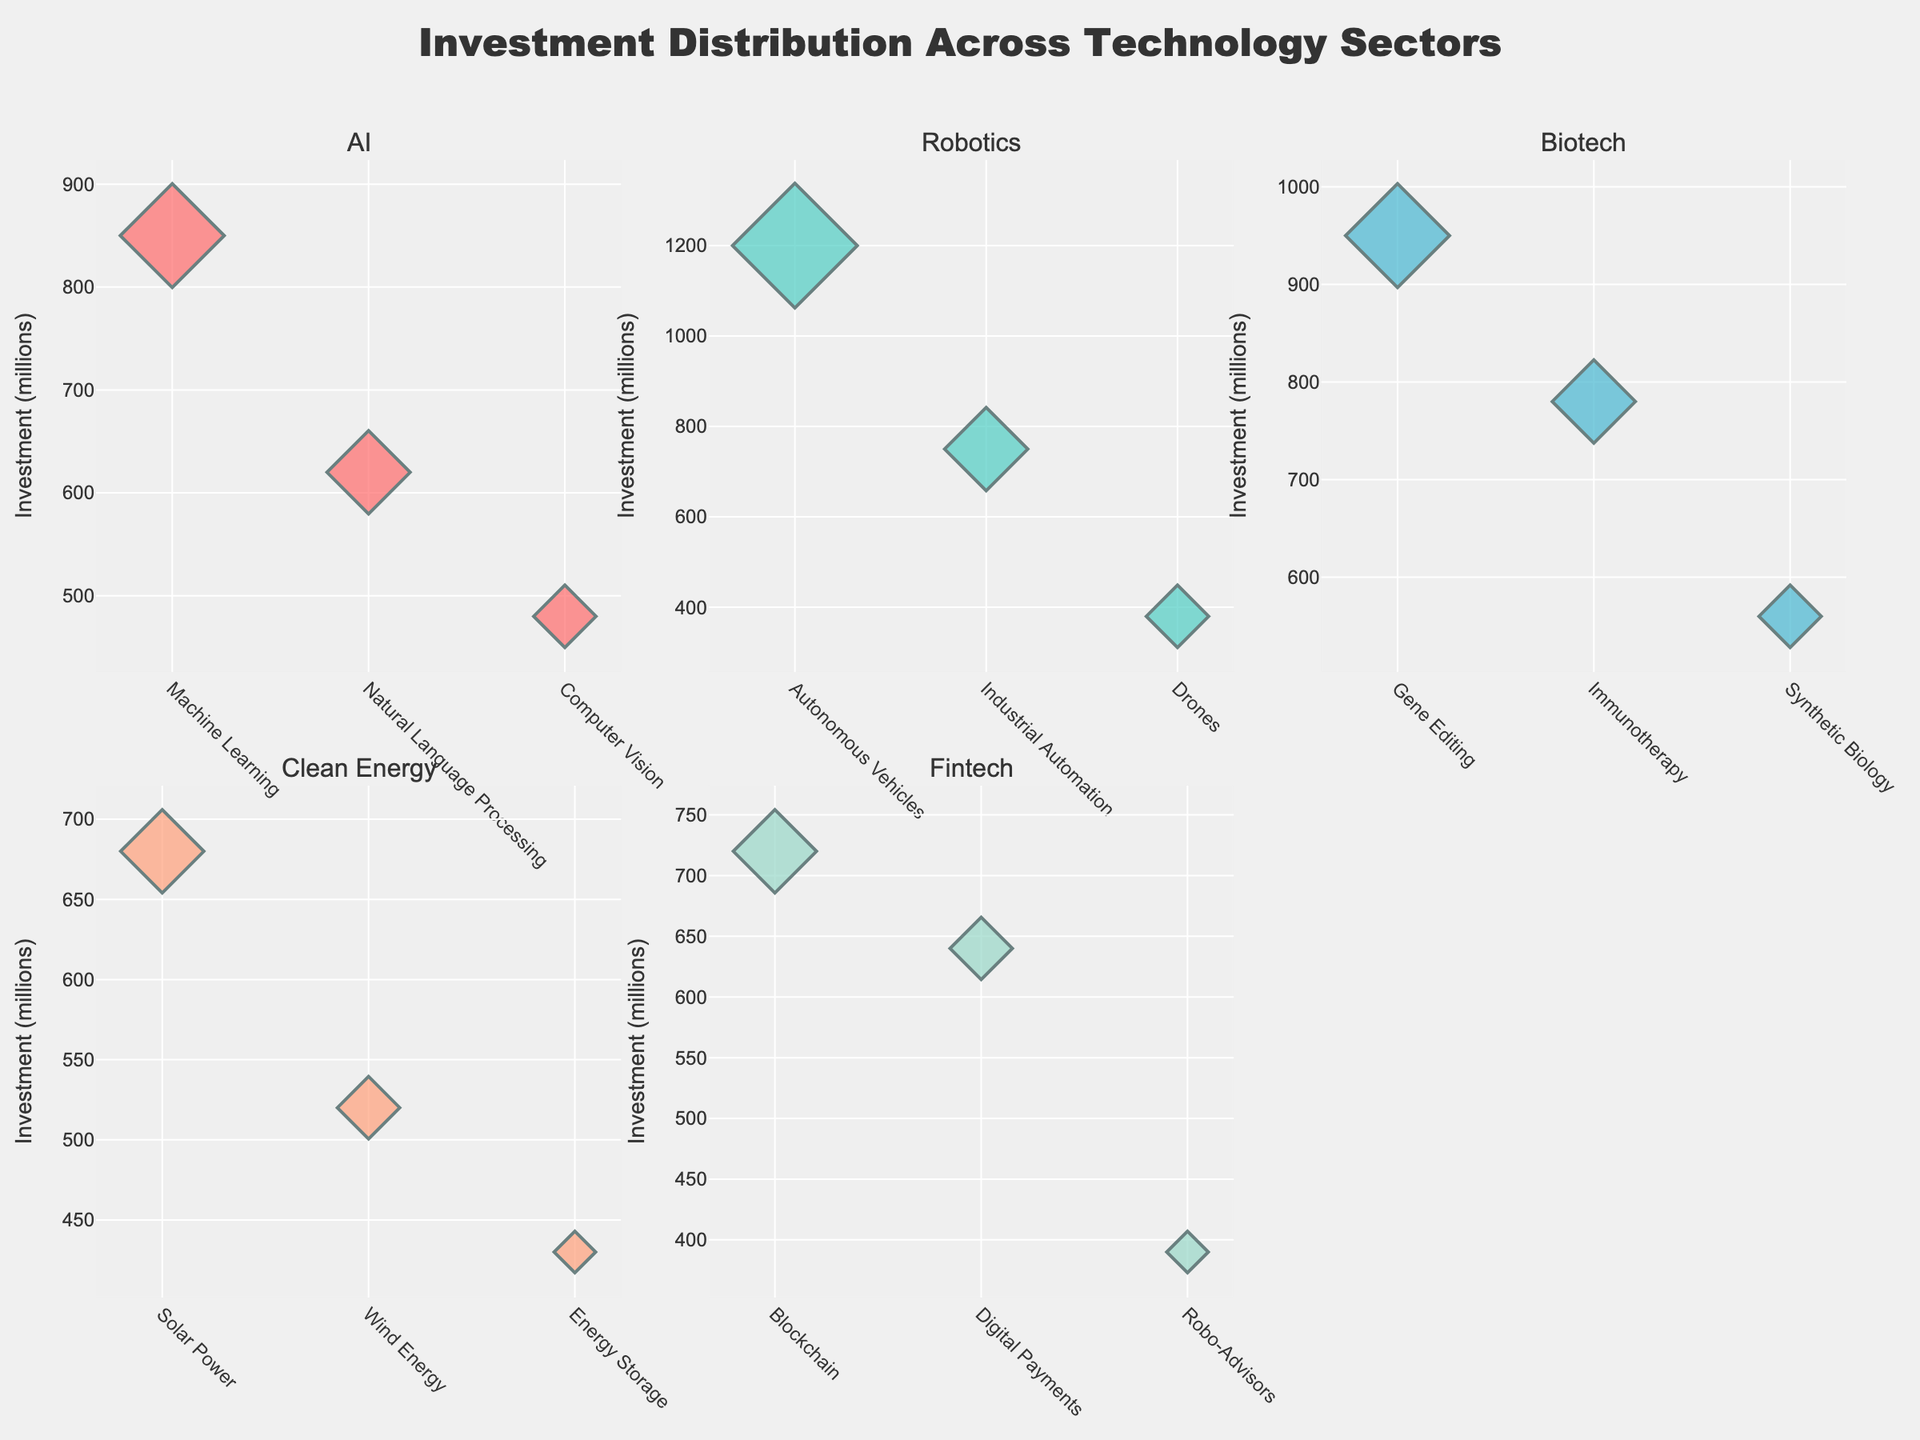What's the title of the figure? The title is prominently displayed at the top and reads 'Seasonal Menu Item Analysis'.
Answer: Seasonal Menu Item Analysis Which season has the highest popularity for any single menu item? By looking at the popularity axis, the Fall season has the Pumpkin Spice Latte with the highest popularity of 98.
Answer: Fall What is the menu item with the lowest profit margin in Summer? By checking the y-axis for Summer, the Watermelon Feta Salad has the lowest profit margin of 20%.
Answer: Watermelon Feta Salad How many data points are there for each season? Each subplot has three bubble markers indicating three data points per season.
Answer: 3 What is the average profit margin of the Winter menu items? The profit margins for Winter are 27, 25, and 32. The average is calculated as (27 + 25 + 32) / 3 = 28.
Answer: 28 Compare the sales volume for the most popular Spring menu item with the least popular Winter menu item. Which has higher sales? The most popular Spring item is Lemon Herb Grilled Chicken with sales of 520. The least popular Winter item is Truffle Mac and Cheese with sales of 470. 520 > 470.
Answer: Lemon Herb Grilled Chicken Which season has the smallest bubble size on the plot? The bubbles represent sales volume with relative sizes. The smallest bubble is in Spring with the Strawberry Spinach Salad having sales of 380.
Answer: Spring What is the total sales volume for Fall menu items? The Fall menu items have sales volumes of 600, 500, and 460. The total sales volume is 600 + 500 + 460 = 1,560.
Answer: 1,560 Which season has the most consistent profit margins across its menu items? By comparing the vertical distribution of bubbles within each subplot, the profit margins in Spring are closely grouped around 18, 22, and 25, suggesting consistent margins.
Answer: Spring What is the distance in popularity between the most and least popular items in Winter? The most popular Winter item is Peppermint Hot Chocolate with a popularity of 96, and the least popular is Truffle Mac and Cheese with 89. The difference is 96 - 89 = 7.
Answer: 7 